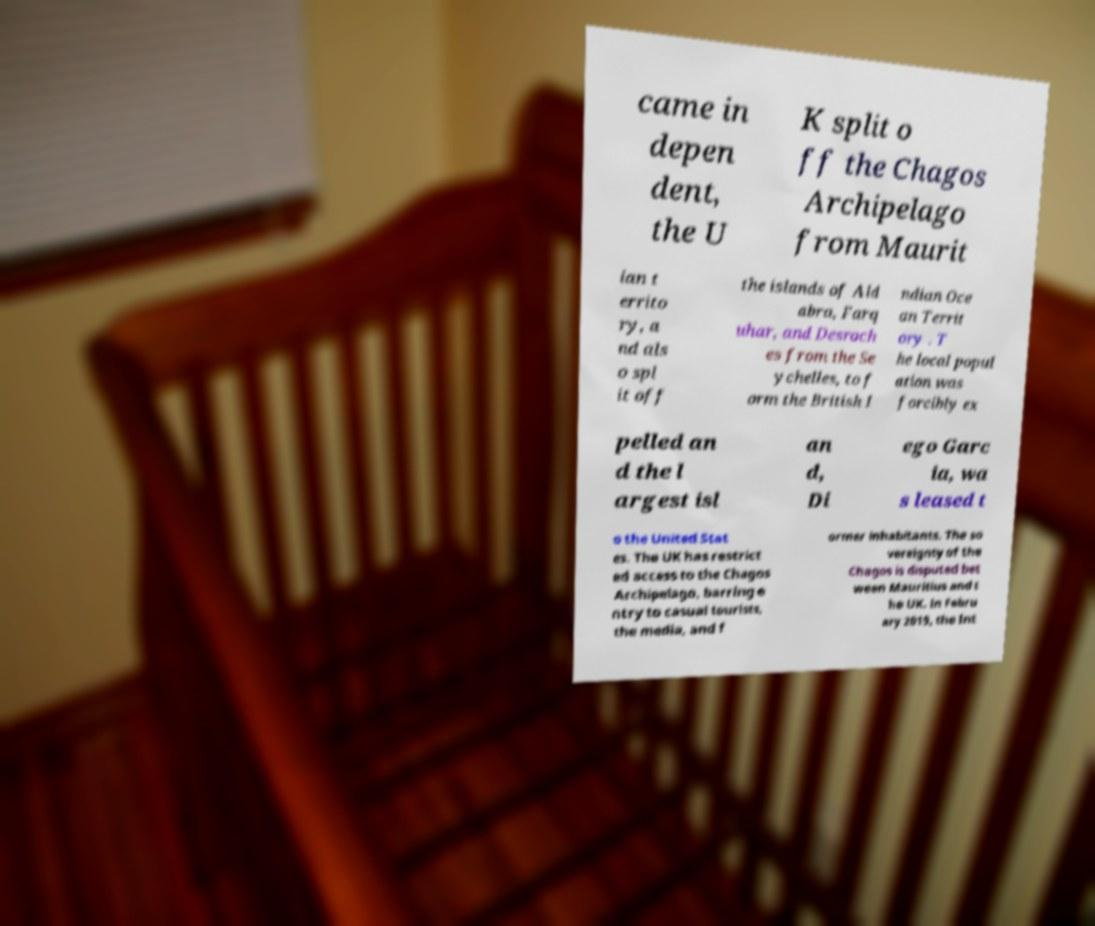Can you read and provide the text displayed in the image?This photo seems to have some interesting text. Can you extract and type it out for me? came in depen dent, the U K split o ff the Chagos Archipelago from Maurit ian t errito ry, a nd als o spl it off the islands of Ald abra, Farq uhar, and Desroch es from the Se ychelles, to f orm the British I ndian Oce an Territ ory . T he local popul ation was forcibly ex pelled an d the l argest isl an d, Di ego Garc ia, wa s leased t o the United Stat es. The UK has restrict ed access to the Chagos Archipelago, barring e ntry to casual tourists, the media, and f ormer inhabitants. The so vereignty of the Chagos is disputed bet ween Mauritius and t he UK. In Febru ary 2019, the Int 